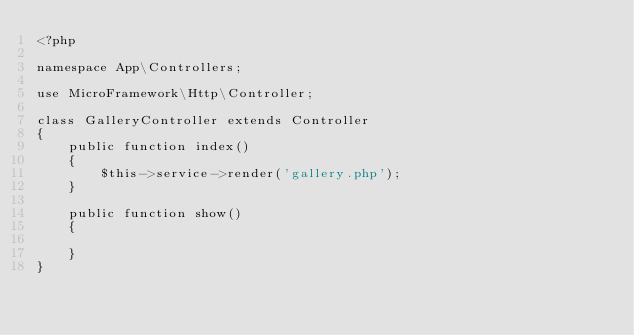Convert code to text. <code><loc_0><loc_0><loc_500><loc_500><_PHP_><?php

namespace App\Controllers;

use MicroFramework\Http\Controller;

class GalleryController extends Controller
{
    public function index()
    {
        $this->service->render('gallery.php');
    }

    public function show()
    {
        
    }
}</code> 